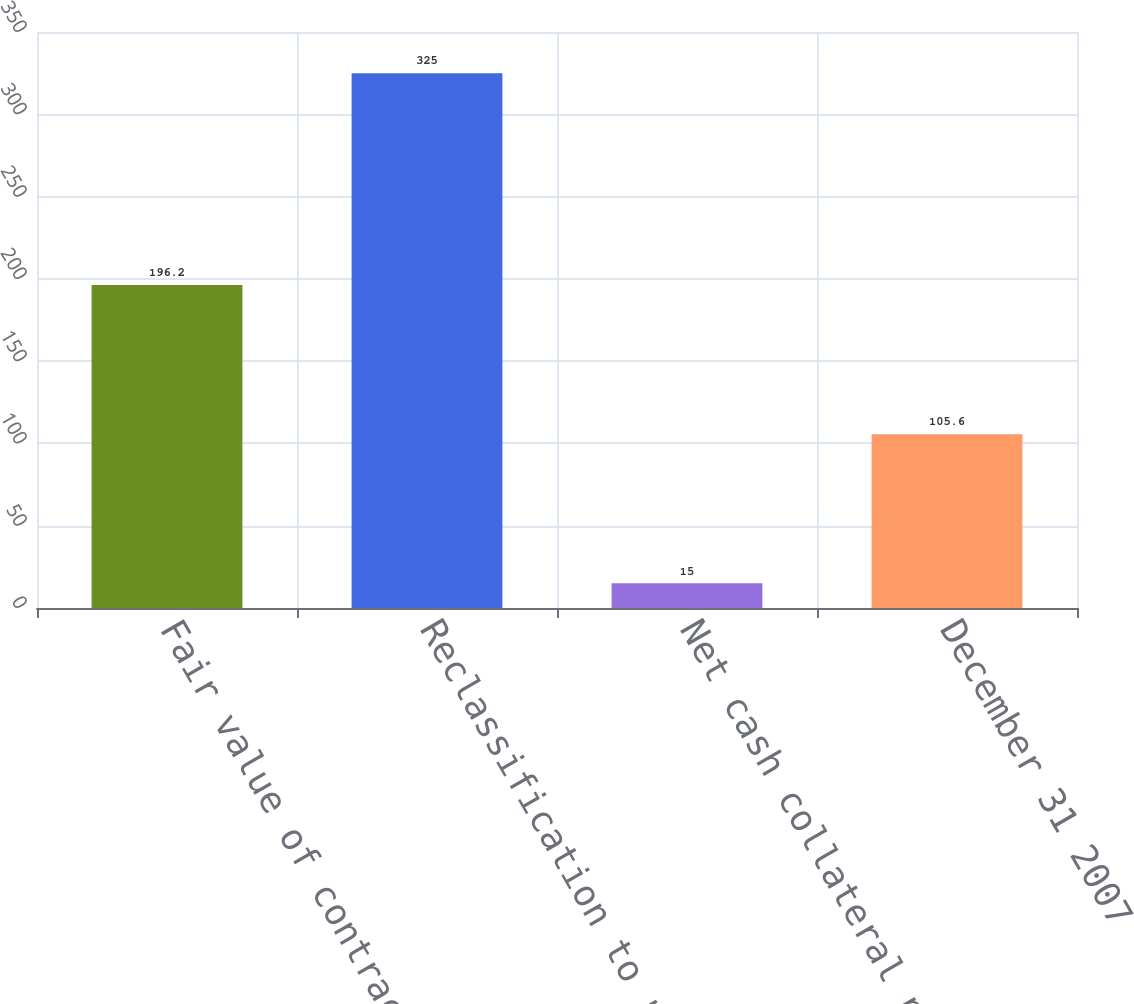<chart> <loc_0><loc_0><loc_500><loc_500><bar_chart><fcel>Fair value of contracts<fcel>Reclassification to realized<fcel>Net cash collateral paid<fcel>December 31 2007<nl><fcel>196.2<fcel>325<fcel>15<fcel>105.6<nl></chart> 